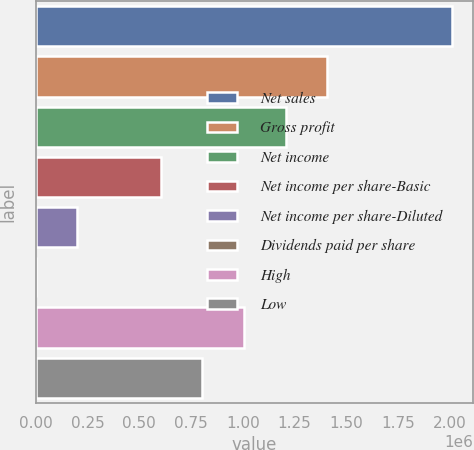Convert chart. <chart><loc_0><loc_0><loc_500><loc_500><bar_chart><fcel>Net sales<fcel>Gross profit<fcel>Net income<fcel>Net income per share-Basic<fcel>Net income per share-Diluted<fcel>Dividends paid per share<fcel>High<fcel>Low<nl><fcel>2.01003e+06<fcel>1.40702e+06<fcel>1.20602e+06<fcel>603008<fcel>201003<fcel>0.54<fcel>1.00501e+06<fcel>804011<nl></chart> 